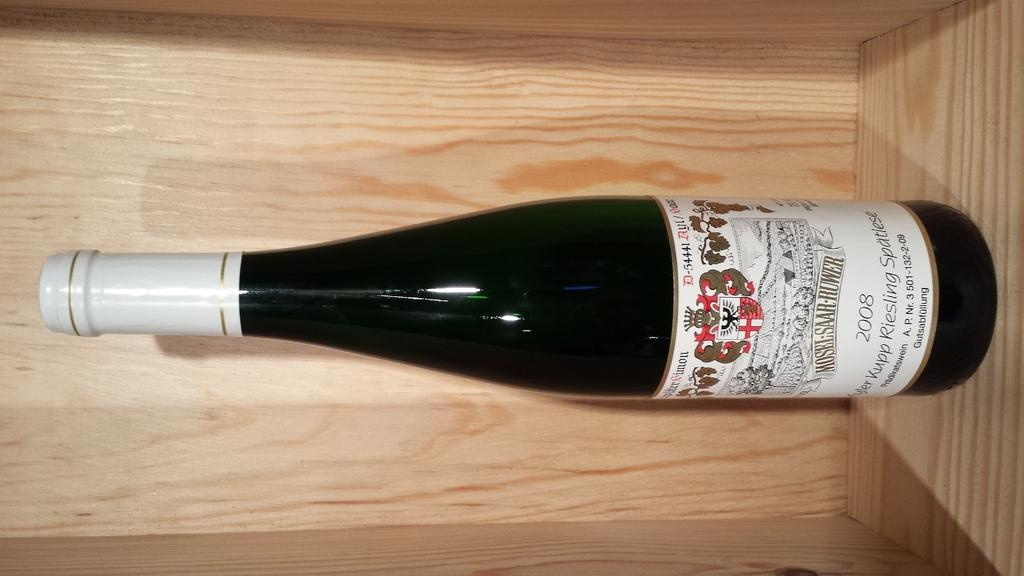<image>
Render a clear and concise summary of the photo. A 2008 bottle of Riesling wine from Mosel-Saar-Ruwer.    r 